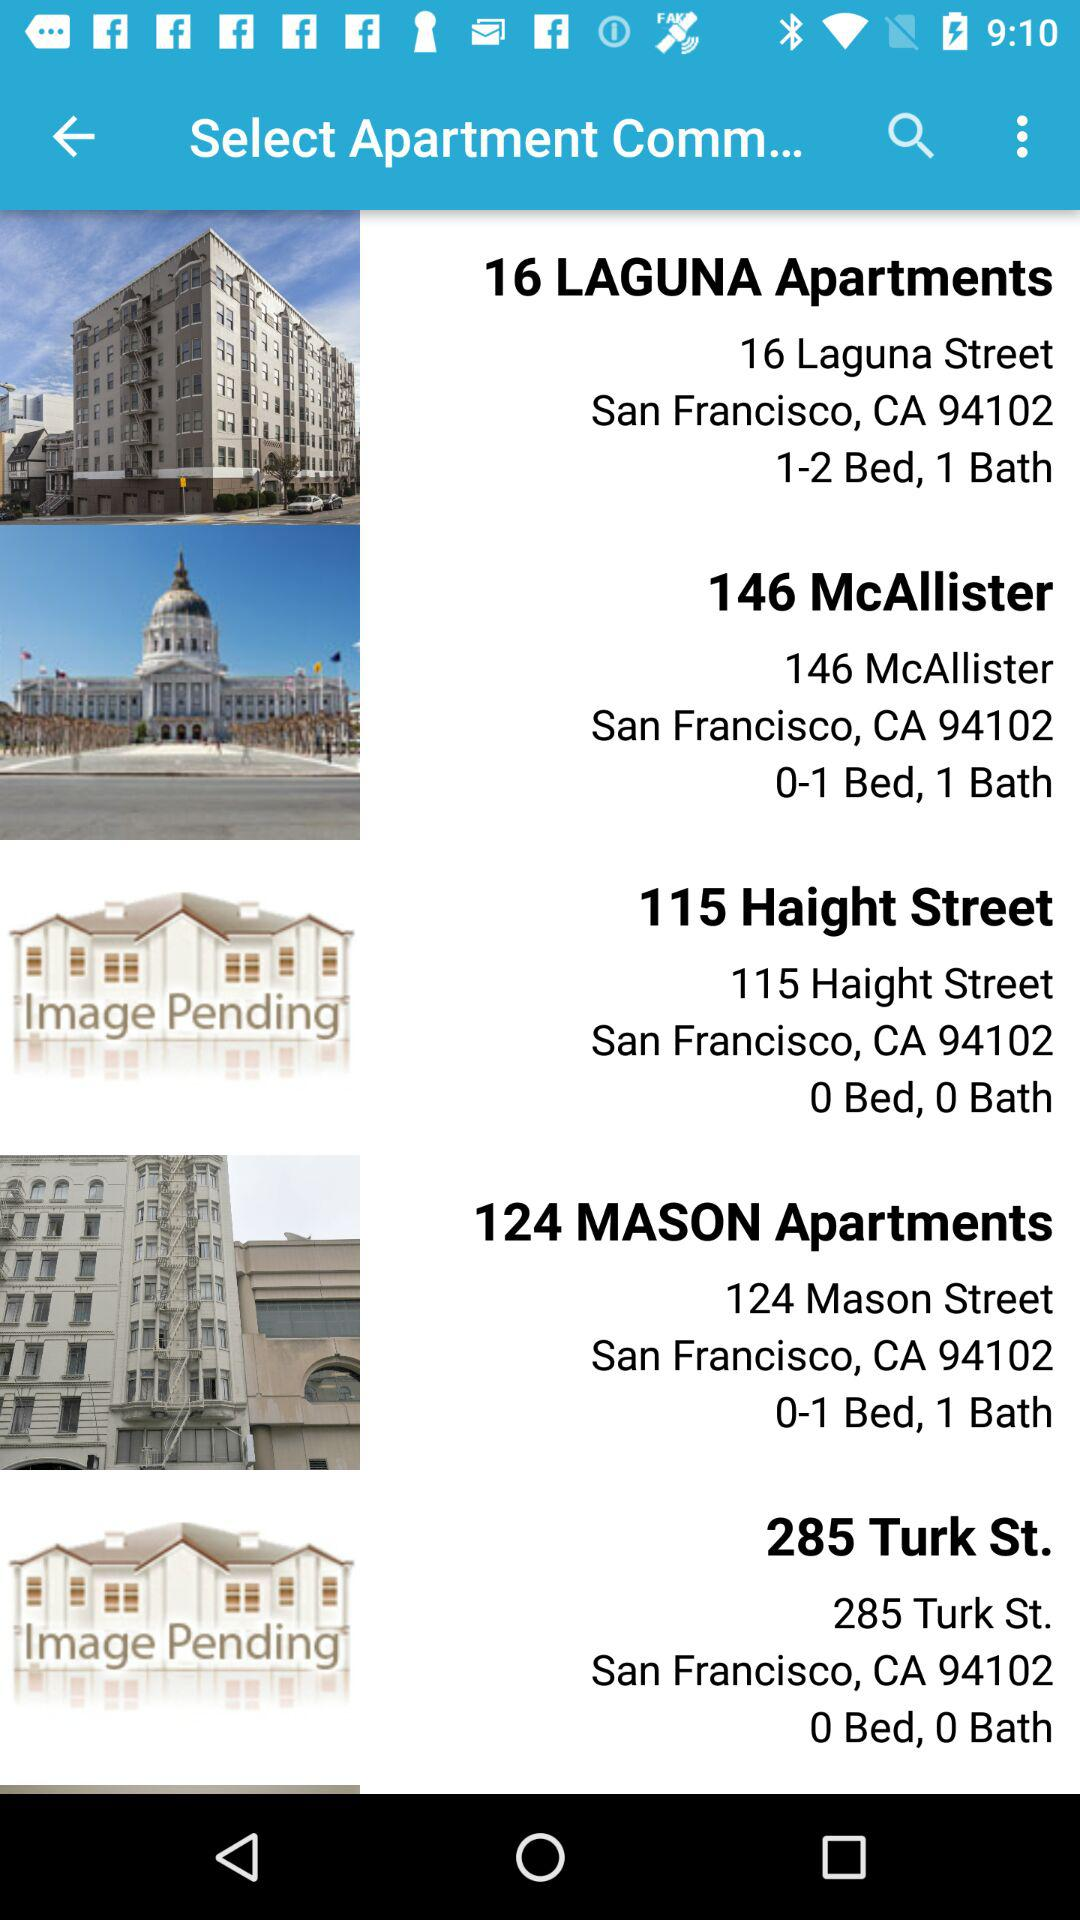What is the address of 115 Haight Street Apartments? The address is 115 Haight Street, San Francisco, CA 94102. 